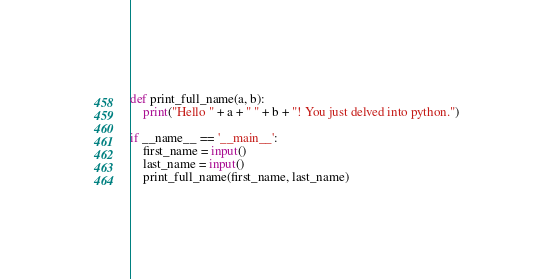<code> <loc_0><loc_0><loc_500><loc_500><_Python_>def print_full_name(a, b):
    print("Hello " + a + " " + b + "! You just delved into python.")

if __name__ == '__main__':
    first_name = input()
    last_name = input()
    print_full_name(first_name, last_name)</code> 